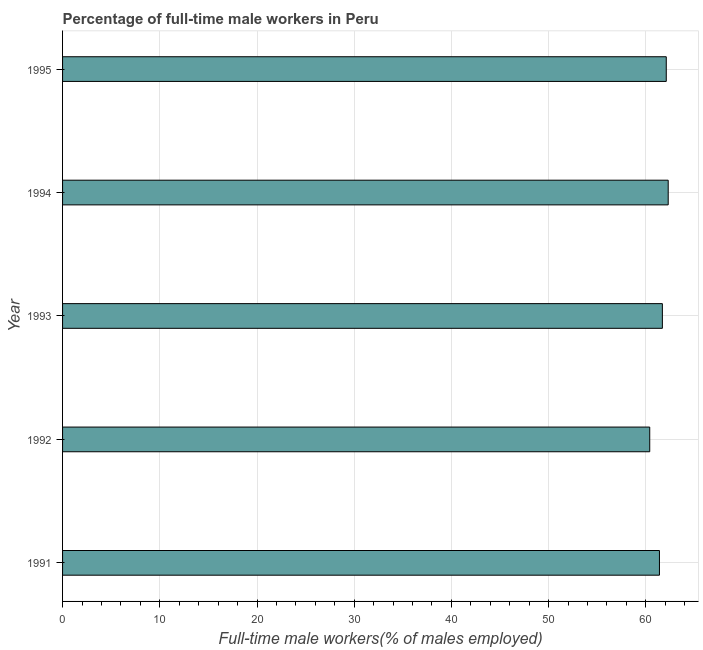Does the graph contain grids?
Your answer should be compact. Yes. What is the title of the graph?
Ensure brevity in your answer.  Percentage of full-time male workers in Peru. What is the label or title of the X-axis?
Make the answer very short. Full-time male workers(% of males employed). What is the label or title of the Y-axis?
Give a very brief answer. Year. What is the percentage of full-time male workers in 1995?
Your response must be concise. 62.1. Across all years, what is the maximum percentage of full-time male workers?
Your response must be concise. 62.3. Across all years, what is the minimum percentage of full-time male workers?
Your response must be concise. 60.4. In which year was the percentage of full-time male workers minimum?
Provide a succinct answer. 1992. What is the sum of the percentage of full-time male workers?
Offer a terse response. 307.9. What is the average percentage of full-time male workers per year?
Your answer should be compact. 61.58. What is the median percentage of full-time male workers?
Offer a terse response. 61.7. In how many years, is the percentage of full-time male workers greater than 54 %?
Offer a terse response. 5. Do a majority of the years between 1991 and 1993 (inclusive) have percentage of full-time male workers greater than 50 %?
Your response must be concise. Yes. What is the ratio of the percentage of full-time male workers in 1991 to that in 1994?
Ensure brevity in your answer.  0.99. Is the percentage of full-time male workers in 1994 less than that in 1995?
Give a very brief answer. No. What is the difference between the highest and the second highest percentage of full-time male workers?
Your answer should be very brief. 0.2. In how many years, is the percentage of full-time male workers greater than the average percentage of full-time male workers taken over all years?
Make the answer very short. 3. Are all the bars in the graph horizontal?
Give a very brief answer. Yes. What is the difference between two consecutive major ticks on the X-axis?
Offer a very short reply. 10. What is the Full-time male workers(% of males employed) in 1991?
Provide a short and direct response. 61.4. What is the Full-time male workers(% of males employed) in 1992?
Your answer should be very brief. 60.4. What is the Full-time male workers(% of males employed) of 1993?
Offer a very short reply. 61.7. What is the Full-time male workers(% of males employed) in 1994?
Your answer should be compact. 62.3. What is the Full-time male workers(% of males employed) in 1995?
Make the answer very short. 62.1. What is the difference between the Full-time male workers(% of males employed) in 1991 and 1992?
Offer a very short reply. 1. What is the difference between the Full-time male workers(% of males employed) in 1991 and 1995?
Keep it short and to the point. -0.7. What is the difference between the Full-time male workers(% of males employed) in 1992 and 1993?
Provide a short and direct response. -1.3. What is the difference between the Full-time male workers(% of males employed) in 1993 and 1994?
Provide a short and direct response. -0.6. What is the difference between the Full-time male workers(% of males employed) in 1993 and 1995?
Provide a short and direct response. -0.4. What is the ratio of the Full-time male workers(% of males employed) in 1991 to that in 1992?
Your answer should be very brief. 1.02. What is the ratio of the Full-time male workers(% of males employed) in 1991 to that in 1993?
Make the answer very short. 0.99. What is the ratio of the Full-time male workers(% of males employed) in 1991 to that in 1995?
Make the answer very short. 0.99. What is the ratio of the Full-time male workers(% of males employed) in 1992 to that in 1995?
Keep it short and to the point. 0.97. 